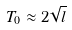Convert formula to latex. <formula><loc_0><loc_0><loc_500><loc_500>T _ { 0 } \approx 2 \sqrt { l }</formula> 